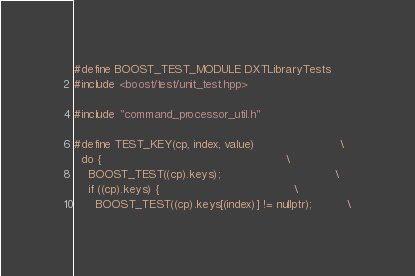Convert code to text. <code><loc_0><loc_0><loc_500><loc_500><_C++_>#define BOOST_TEST_MODULE DXTLibraryTests
#include <boost/test/unit_test.hpp>

#include "command_processor_util.h"

#define TEST_KEY(cp, index, value)                        \
  do {                                                    \
    BOOST_TEST((cp).keys);                                \
    if ((cp).keys) {                                      \
      BOOST_TEST((cp).keys[(index)] != nullptr);          \</code> 